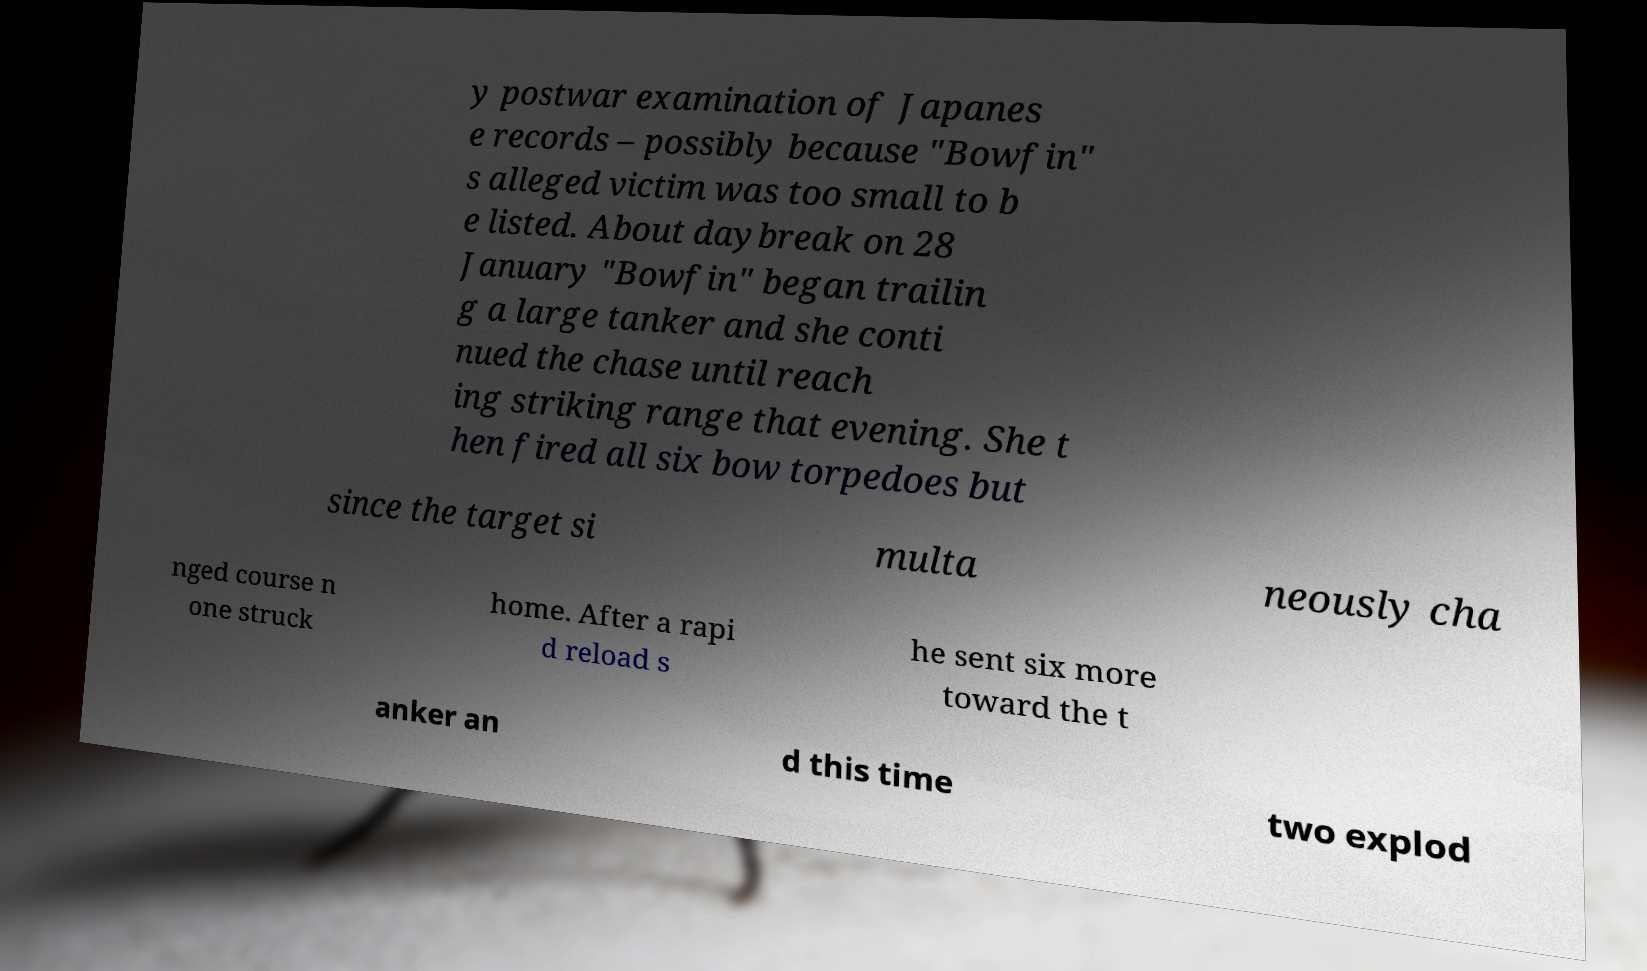Please read and relay the text visible in this image. What does it say? y postwar examination of Japanes e records – possibly because "Bowfin" s alleged victim was too small to b e listed. About daybreak on 28 January "Bowfin" began trailin g a large tanker and she conti nued the chase until reach ing striking range that evening. She t hen fired all six bow torpedoes but since the target si multa neously cha nged course n one struck home. After a rapi d reload s he sent six more toward the t anker an d this time two explod 